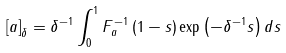<formula> <loc_0><loc_0><loc_500><loc_500>\left [ a \right ] _ { \delta } = \delta ^ { - 1 } \int _ { 0 } ^ { 1 } F _ { a } ^ { - 1 } \left ( 1 - s \right ) \exp \left ( - \delta ^ { - 1 } s \right ) d s</formula> 